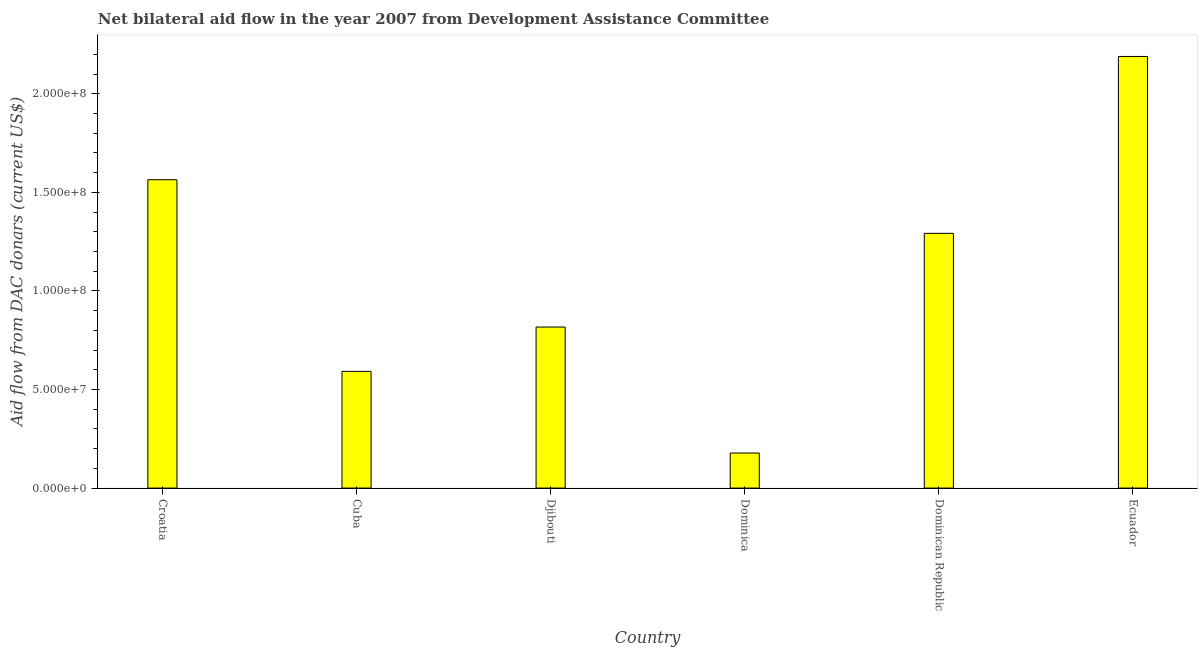Does the graph contain any zero values?
Provide a succinct answer. No. What is the title of the graph?
Provide a short and direct response. Net bilateral aid flow in the year 2007 from Development Assistance Committee. What is the label or title of the Y-axis?
Provide a short and direct response. Aid flow from DAC donars (current US$). What is the net bilateral aid flows from dac donors in Ecuador?
Offer a terse response. 2.19e+08. Across all countries, what is the maximum net bilateral aid flows from dac donors?
Keep it short and to the point. 2.19e+08. Across all countries, what is the minimum net bilateral aid flows from dac donors?
Ensure brevity in your answer.  1.78e+07. In which country was the net bilateral aid flows from dac donors maximum?
Offer a terse response. Ecuador. In which country was the net bilateral aid flows from dac donors minimum?
Make the answer very short. Dominica. What is the sum of the net bilateral aid flows from dac donors?
Give a very brief answer. 6.63e+08. What is the difference between the net bilateral aid flows from dac donors in Djibouti and Dominica?
Your answer should be very brief. 6.39e+07. What is the average net bilateral aid flows from dac donors per country?
Offer a terse response. 1.11e+08. What is the median net bilateral aid flows from dac donors?
Provide a succinct answer. 1.05e+08. What is the ratio of the net bilateral aid flows from dac donors in Dominican Republic to that in Ecuador?
Ensure brevity in your answer.  0.59. What is the difference between the highest and the second highest net bilateral aid flows from dac donors?
Provide a short and direct response. 6.25e+07. Is the sum of the net bilateral aid flows from dac donors in Croatia and Cuba greater than the maximum net bilateral aid flows from dac donors across all countries?
Provide a succinct answer. No. What is the difference between the highest and the lowest net bilateral aid flows from dac donors?
Make the answer very short. 2.01e+08. In how many countries, is the net bilateral aid flows from dac donors greater than the average net bilateral aid flows from dac donors taken over all countries?
Offer a terse response. 3. Are all the bars in the graph horizontal?
Your response must be concise. No. How many countries are there in the graph?
Your answer should be very brief. 6. What is the difference between two consecutive major ticks on the Y-axis?
Keep it short and to the point. 5.00e+07. Are the values on the major ticks of Y-axis written in scientific E-notation?
Your response must be concise. Yes. What is the Aid flow from DAC donars (current US$) of Croatia?
Your response must be concise. 1.56e+08. What is the Aid flow from DAC donars (current US$) of Cuba?
Ensure brevity in your answer.  5.92e+07. What is the Aid flow from DAC donars (current US$) of Djibouti?
Your answer should be very brief. 8.17e+07. What is the Aid flow from DAC donars (current US$) of Dominica?
Offer a terse response. 1.78e+07. What is the Aid flow from DAC donars (current US$) of Dominican Republic?
Your answer should be compact. 1.29e+08. What is the Aid flow from DAC donars (current US$) of Ecuador?
Give a very brief answer. 2.19e+08. What is the difference between the Aid flow from DAC donars (current US$) in Croatia and Cuba?
Offer a terse response. 9.72e+07. What is the difference between the Aid flow from DAC donars (current US$) in Croatia and Djibouti?
Make the answer very short. 7.47e+07. What is the difference between the Aid flow from DAC donars (current US$) in Croatia and Dominica?
Your response must be concise. 1.39e+08. What is the difference between the Aid flow from DAC donars (current US$) in Croatia and Dominican Republic?
Your answer should be compact. 2.72e+07. What is the difference between the Aid flow from DAC donars (current US$) in Croatia and Ecuador?
Make the answer very short. -6.25e+07. What is the difference between the Aid flow from DAC donars (current US$) in Cuba and Djibouti?
Give a very brief answer. -2.25e+07. What is the difference between the Aid flow from DAC donars (current US$) in Cuba and Dominica?
Provide a succinct answer. 4.14e+07. What is the difference between the Aid flow from DAC donars (current US$) in Cuba and Dominican Republic?
Offer a terse response. -7.00e+07. What is the difference between the Aid flow from DAC donars (current US$) in Cuba and Ecuador?
Keep it short and to the point. -1.60e+08. What is the difference between the Aid flow from DAC donars (current US$) in Djibouti and Dominica?
Ensure brevity in your answer.  6.39e+07. What is the difference between the Aid flow from DAC donars (current US$) in Djibouti and Dominican Republic?
Offer a very short reply. -4.75e+07. What is the difference between the Aid flow from DAC donars (current US$) in Djibouti and Ecuador?
Ensure brevity in your answer.  -1.37e+08. What is the difference between the Aid flow from DAC donars (current US$) in Dominica and Dominican Republic?
Give a very brief answer. -1.11e+08. What is the difference between the Aid flow from DAC donars (current US$) in Dominica and Ecuador?
Make the answer very short. -2.01e+08. What is the difference between the Aid flow from DAC donars (current US$) in Dominican Republic and Ecuador?
Your response must be concise. -8.97e+07. What is the ratio of the Aid flow from DAC donars (current US$) in Croatia to that in Cuba?
Offer a very short reply. 2.64. What is the ratio of the Aid flow from DAC donars (current US$) in Croatia to that in Djibouti?
Ensure brevity in your answer.  1.92. What is the ratio of the Aid flow from DAC donars (current US$) in Croatia to that in Dominica?
Ensure brevity in your answer.  8.79. What is the ratio of the Aid flow from DAC donars (current US$) in Croatia to that in Dominican Republic?
Your response must be concise. 1.21. What is the ratio of the Aid flow from DAC donars (current US$) in Croatia to that in Ecuador?
Your answer should be compact. 0.71. What is the ratio of the Aid flow from DAC donars (current US$) in Cuba to that in Djibouti?
Provide a short and direct response. 0.72. What is the ratio of the Aid flow from DAC donars (current US$) in Cuba to that in Dominica?
Give a very brief answer. 3.33. What is the ratio of the Aid flow from DAC donars (current US$) in Cuba to that in Dominican Republic?
Keep it short and to the point. 0.46. What is the ratio of the Aid flow from DAC donars (current US$) in Cuba to that in Ecuador?
Provide a succinct answer. 0.27. What is the ratio of the Aid flow from DAC donars (current US$) in Djibouti to that in Dominica?
Your answer should be compact. 4.59. What is the ratio of the Aid flow from DAC donars (current US$) in Djibouti to that in Dominican Republic?
Offer a terse response. 0.63. What is the ratio of the Aid flow from DAC donars (current US$) in Djibouti to that in Ecuador?
Your response must be concise. 0.37. What is the ratio of the Aid flow from DAC donars (current US$) in Dominica to that in Dominican Republic?
Make the answer very short. 0.14. What is the ratio of the Aid flow from DAC donars (current US$) in Dominica to that in Ecuador?
Give a very brief answer. 0.08. What is the ratio of the Aid flow from DAC donars (current US$) in Dominican Republic to that in Ecuador?
Make the answer very short. 0.59. 